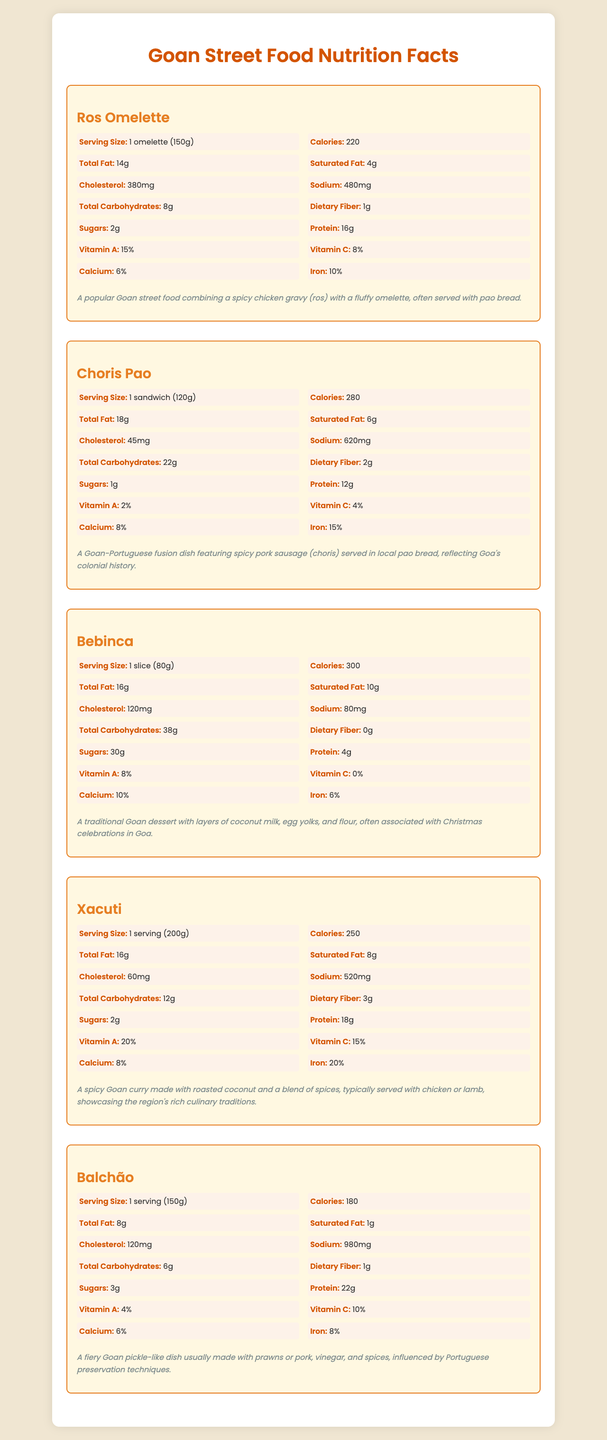who has the highest sodium content? Balchão has 980mg of sodium.
Answer: Balchão which food item offers the highest protein content? Balchão has the highest protein content at 22g.
Answer: Balchão how much iron does the Xacuti provide as a percentage of daily value? The iron content in Xacuti is listed as 20%.
Answer: 20% what is the serving size of Ros Omelette? The serving size for Ros Omelette is 1 omelette (150g).
Answer: 1 omelette (150g) how many calories does one slice of Bebinca contain? One slice of Bebinca contains 300 calories.
Answer: 300 between Ros Omelette and Choris Pao, which has more total fat? Ros Omelette has 14g of total fat, while Choris Pao has 18g.
Answer: Choris Pao which food item contains the highest amount of sugars? Bebinca contains 30g of sugars.
Answer: Bebinca which food item has the lowest cholesterol content? A. Ros Omelette B. Choris Pao C. Bebinca D. Xacuti E. Balchão Choris Pao has the lowest cholesterol content at 45mg.
Answer: B. Choris Pao which dish provides the highest percentage of Vitamin C? A. Ros Omelette B. Choris Pao C. Bebinca D. Xacuti E. Balchão Xacuti provides 15% of the daily value of Vitamin C.
Answer: D. Xacuti does Balchão contain any dietary fiber? Balchão contains 1g of dietary fiber as indicated in the nutrition facts.
Answer: Yes summarize the main idea of the goan street food nutrition facts document. The document systematically presents the nutritional content and brief descriptions of five Goan street foods to inform readers about their health benefits and culinary backgrounds.
Answer: The document provides detailed nutritional information for five popular Goan street foods, including Ros Omelette, Choris Pao, Bebinca, Xacuti, and Balchão. For each dish, information such as serving size, calories, total fat, saturated fat, cholesterol, sodium, total carbohydrates, dietary fiber, sugars, protein, and percentages of Vitamin A, Vitamin C, calcium, and iron is provided. Descriptions of each food item are also included. which food item has the highest percentage of calcium? Bebinca has the highest calcium content at 10%.
Answer: Bebinca how many grams of carbohydrates are in one serving of Xacuti? One serving of Xacuti contains 12g of total carbohydrates.
Answer: 12g what type of food is incorporated in Choris Pao to make it a Goan-Portuguese fusion dish? Choris Pao features spicy pork sausage (choris), which fuses Goan and Portuguese culinary elements.
Answer: Spicy pork sausage (choris) what is the main spice used in Xacuti? The main spice used in Xacuti is not detailed in the provided nutrition facts or descriptions.
Answer: Not enough information compare the calories among Ros Omelette, Choris Pao, and Bebinca. Ros Omelette has 220 calories, Choris Pao has 280 calories, and Bebinca has 300 calories.
Answer: Ros Omelette: 220, Choris Pao: 280, Bebinca: 300 